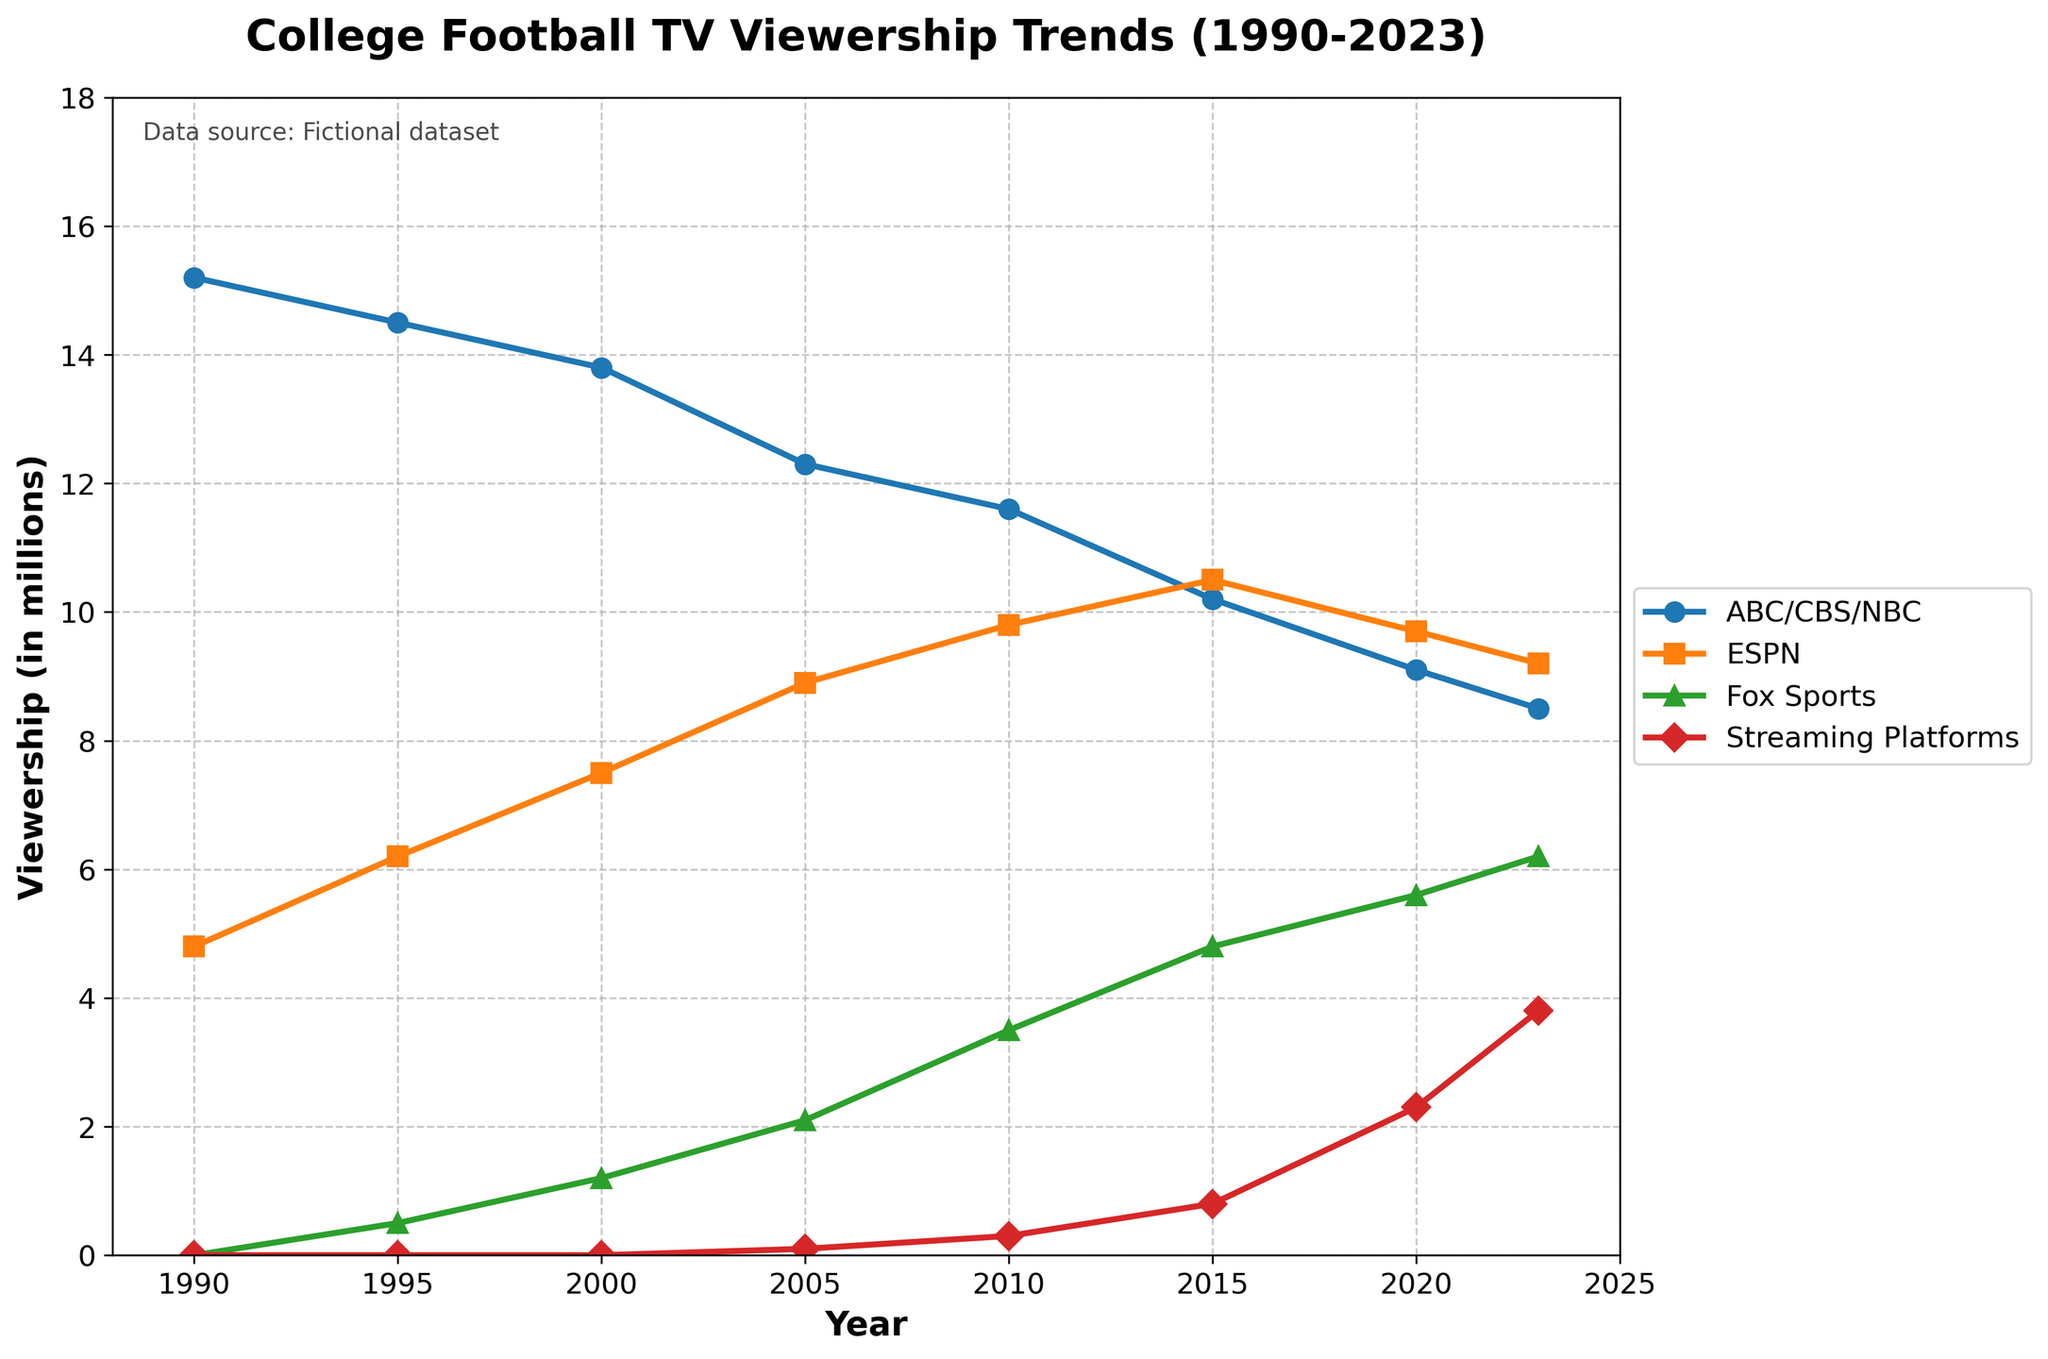What is the difference in viewership between ABC/CBS/NBC and ESPN in 1990? The viewership for ABC/CBS/NBC in 1990 is 15.2 million and for ESPN, it is 4.8 million. The difference is 15.2 - 4.8 = 10.4 million.
Answer: 10.4 million What year did streaming platforms first appear in the data, and what was their viewership at that time? Streaming platforms first appeared in the data in 2005 with a viewership of 0.1 million.
Answer: 2005, 0.1 million Which year had the highest total viewership across all platforms combined? To find the highest total viewership, we sum the viewership of all platforms for each year. 1990 has the highest total viewership: 15.2 + 4.8 + 0 + 0 = 20 million.
Answer: 1990 In which year did ESPN's viewership surpass that of ABC/CBS/NBC? Comparing the viewership each year, in 2015, ESPN has 10.5 million viewers and ABC/CBS/NBC has 10.2 million viewers. Therefore, ESPN surpassed ABC/CBS/NBC in 2015.
Answer: 2015 What is the average viewership of Fox Sports from 2000 to 2023? The viewership figures for Fox Sports from 2000 to 2023 are 1.2, 2.1, 3.5, 4.8, 5.6, and 6.2 million. The sum is 23.4 million. The average is 23.4 / 6 = 3.9 million.
Answer: 3.9 million Between 1990 and 2023, how much has the viewership of traditional network broadcasts (ABC/CBS/NBC) declined? The viewership of traditional network broadcasts was 15.2 million in 1990 and 8.5 million in 2023. The decline is 15.2 - 8.5 = 6.7 million.
Answer: 6.7 million Which platform had the highest growth in viewership between 1990 and 2023? Calculating the difference between 2023 and 1990, the growth figures are: ABC/CBS/NBC: 8.5 - 15.2 = -6.7 million, ESPN: 9.2 - 4.8 = 4.4 million, Fox Sports: 6.2 - 0 = 6.2 million, Streaming Platforms: 3.8 - 0 = 3.8 million. Fox Sports had the highest growth: 6.2 million.
Answer: Fox Sports Which platform shows the most consistent increase in viewership over the 30-year period? By examining the trend lines, ESPN's viewership steadily increases every five years from 1990 to 2023 without significant dips.
Answer: ESPN What was the viewership for ESPN and Fox Sports combined in 2010? The viewership for ESPN in 2010 is 9.8 million and for Fox Sports, it is 3.5 million. The combined viewership is 9.8 + 3.5 = 13.3 million.
Answer: 13.3 million What is the rate of increase in viewership for Streaming Platforms from 2005 to 2023? The viewership for Streaming Platforms in 2005 is 0.1 million and in 2023 is 3.8 million. The rate of increase is (3.8 - 0.1) / (2023 - 2005) = 3.7 / 18 ≈ 0.206 million per year.
Answer: 0.206 million per year 